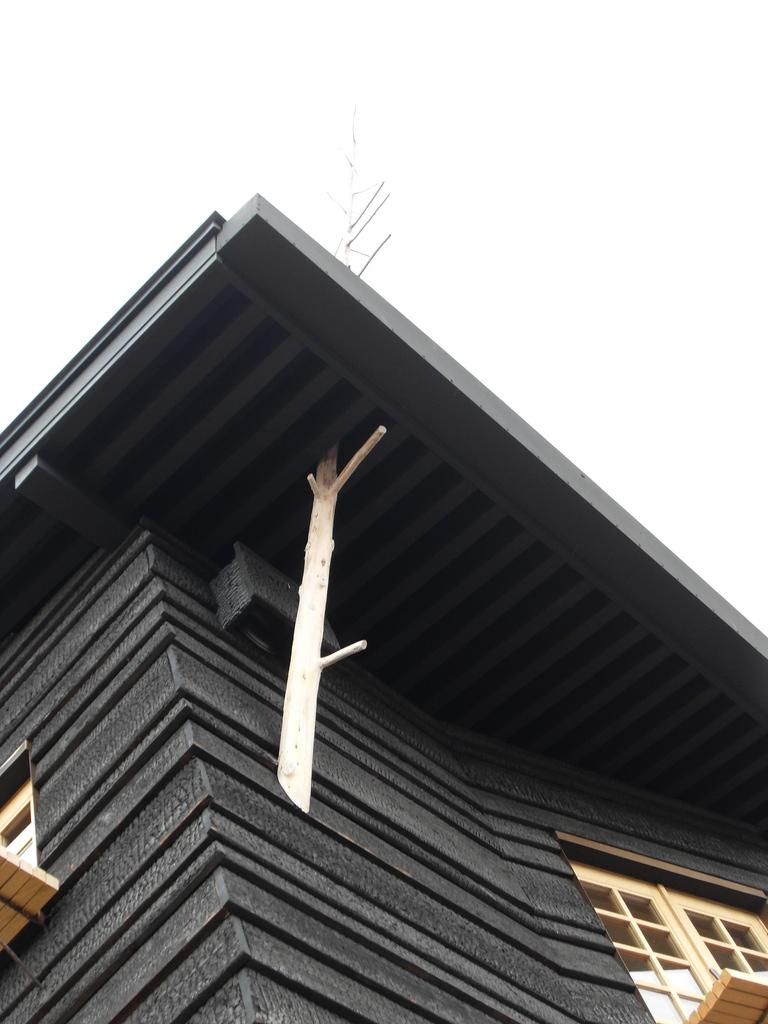Where was the picture taken? The picture was clicked outside. What is the main subject in the foreground of the image? There is a building in the foreground of the image. What feature can be seen on the building? The building has windows. What can be seen in the background of the image? There is a sky visible in the background of the image. What type of objects are present in the background of the image? There are metal rods in the background of the image. What type of chair is visible in the image? There is no chair present in the image. What type of crate can be seen holding the eggnog in the image? There is no crate or eggnog present in the image. 